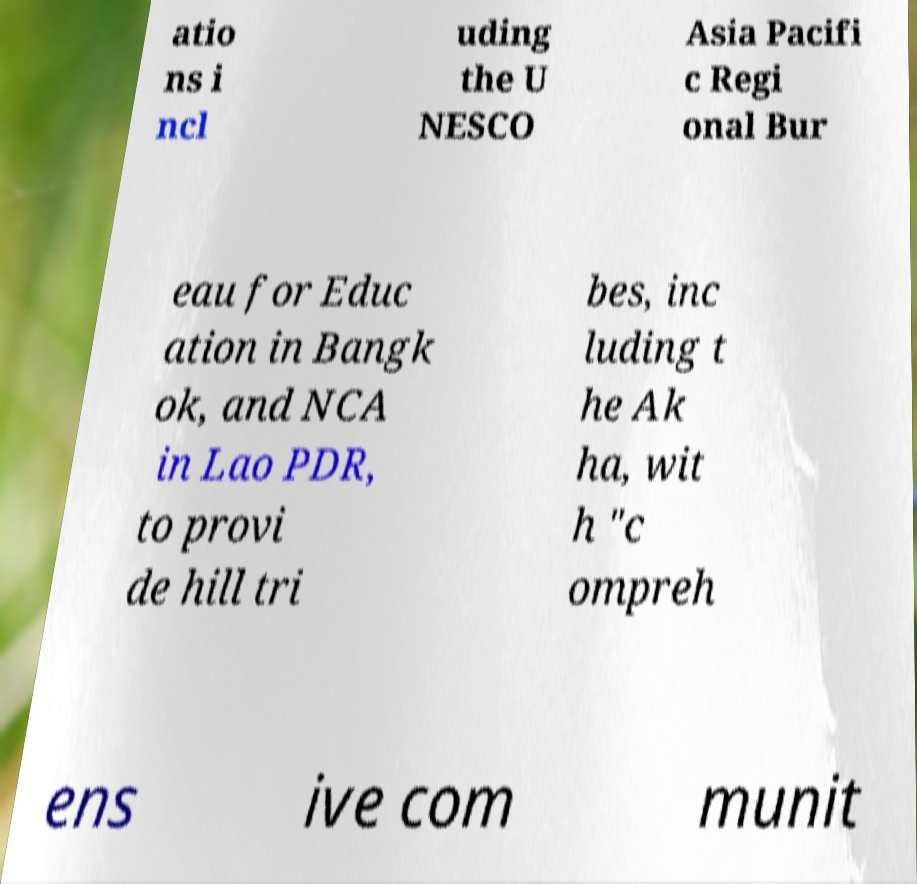Could you extract and type out the text from this image? atio ns i ncl uding the U NESCO Asia Pacifi c Regi onal Bur eau for Educ ation in Bangk ok, and NCA in Lao PDR, to provi de hill tri bes, inc luding t he Ak ha, wit h "c ompreh ens ive com munit 